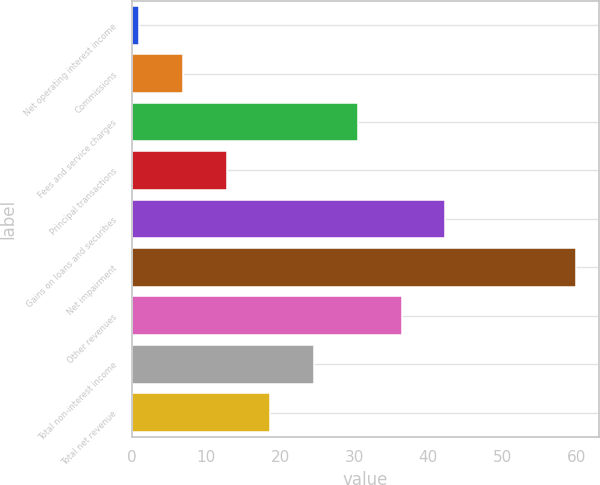Convert chart. <chart><loc_0><loc_0><loc_500><loc_500><bar_chart><fcel>Net operating interest income<fcel>Commissions<fcel>Fees and service charges<fcel>Principal transactions<fcel>Gains on loans and securities<fcel>Net impairment<fcel>Other revenues<fcel>Total non-interest income<fcel>Total net revenue<nl><fcel>1<fcel>6.9<fcel>30.5<fcel>12.8<fcel>42.3<fcel>60<fcel>36.4<fcel>24.6<fcel>18.7<nl></chart> 